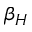<formula> <loc_0><loc_0><loc_500><loc_500>\beta _ { H }</formula> 